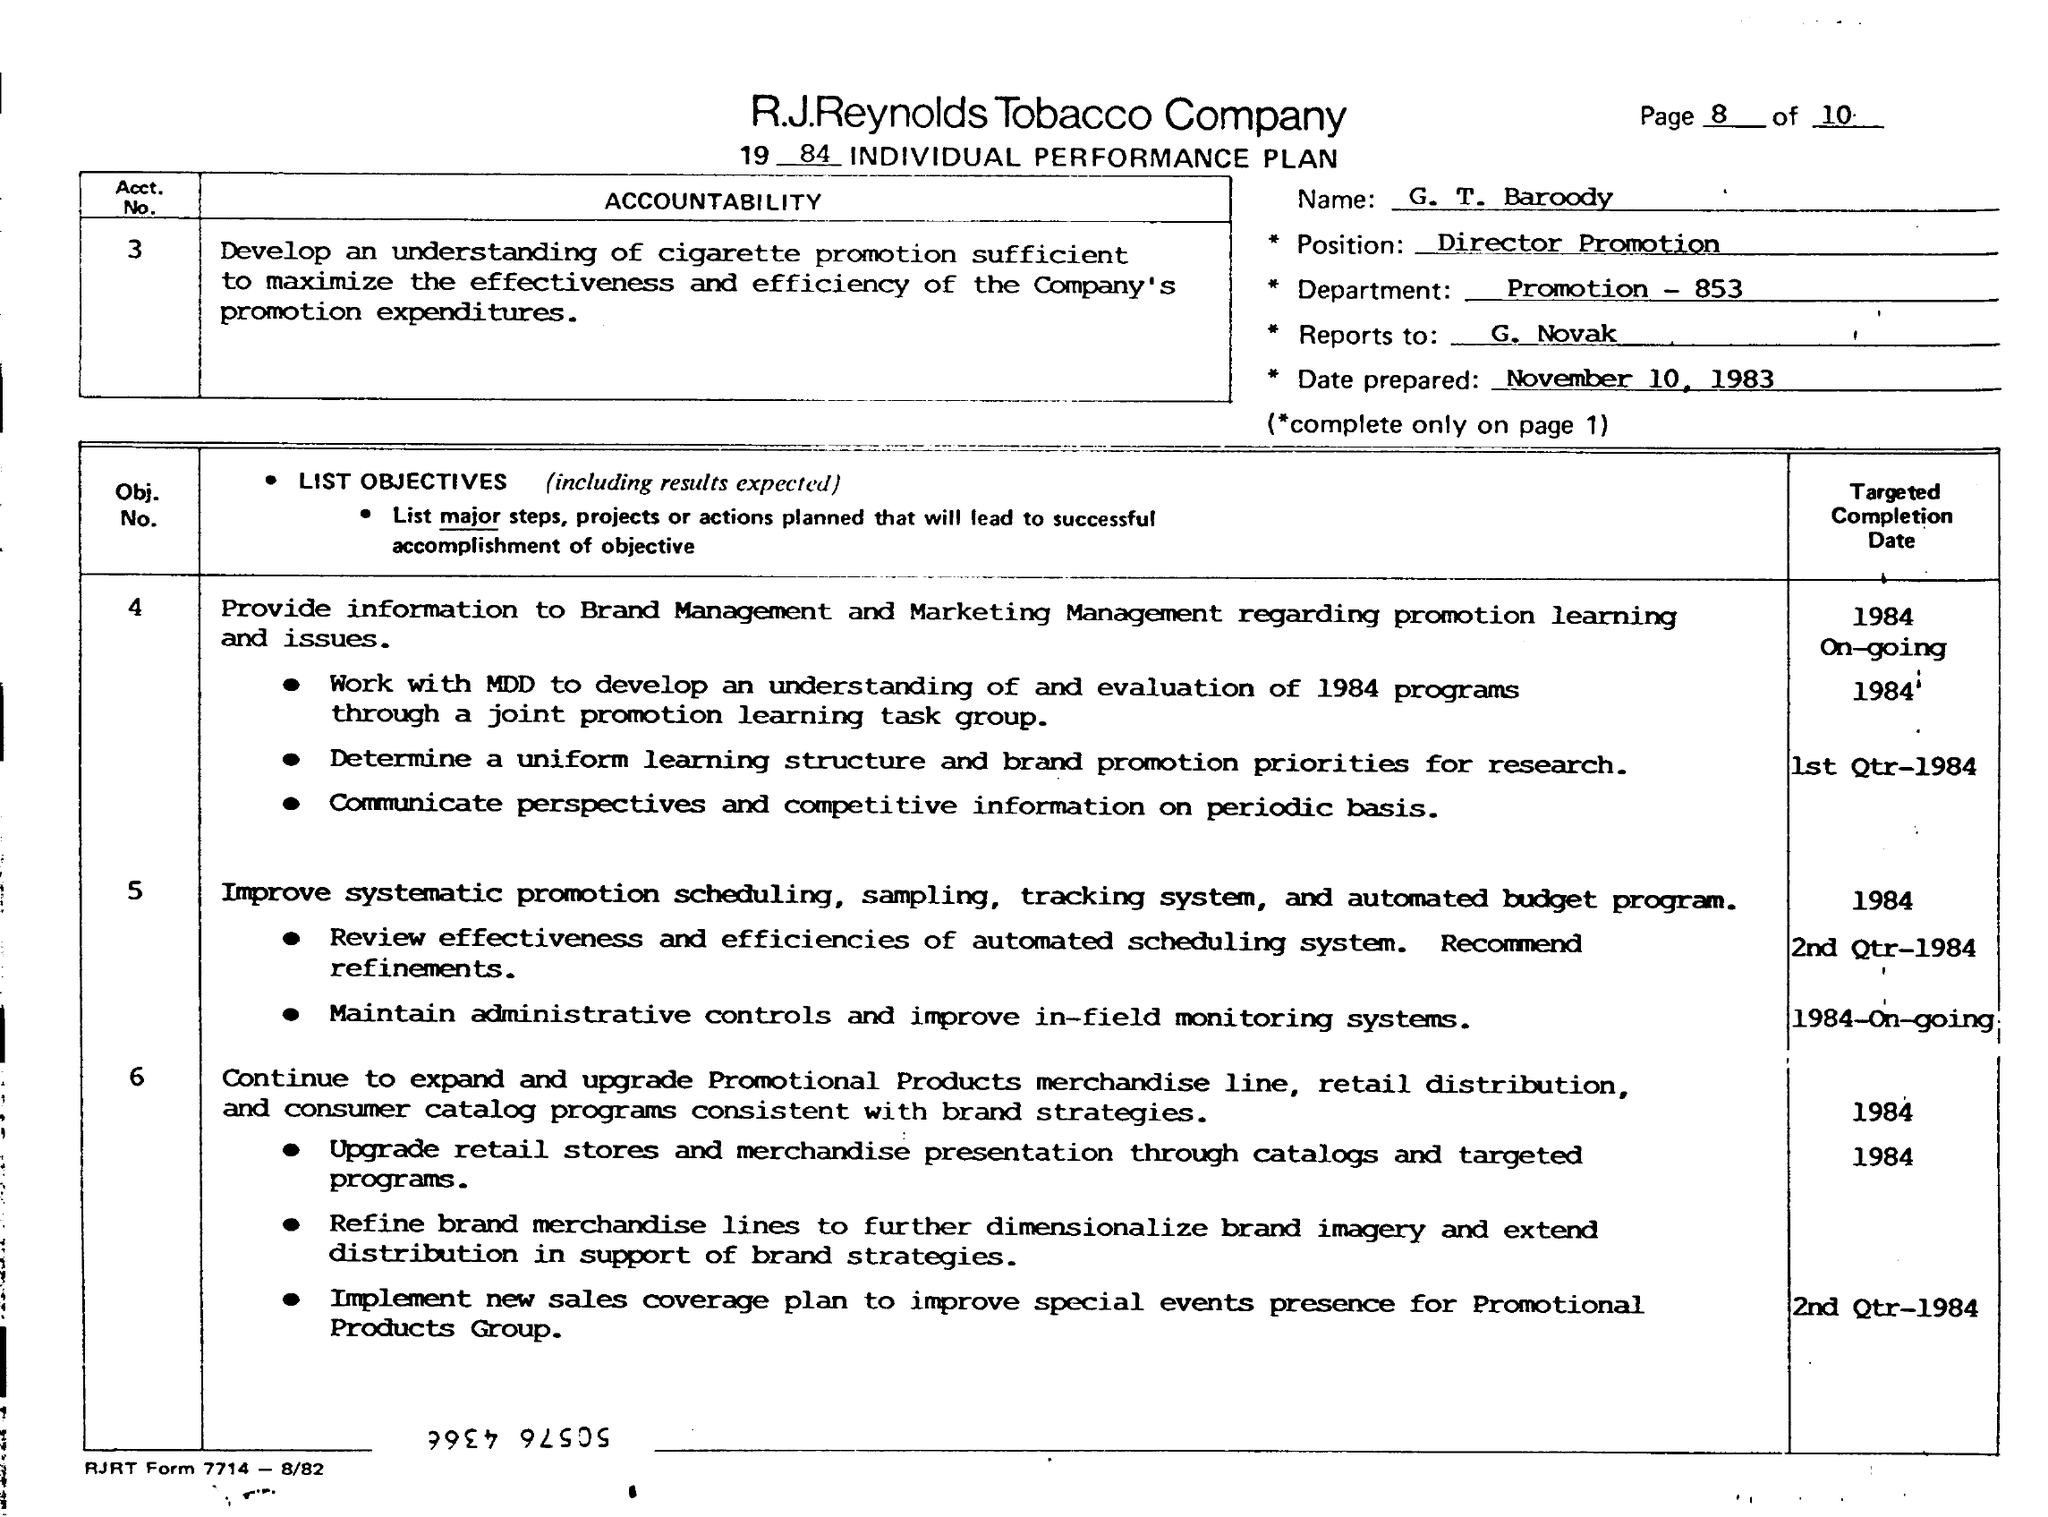Communicate perspectives and competitive information are on which basis?
Provide a short and direct response. Periodic basis. 